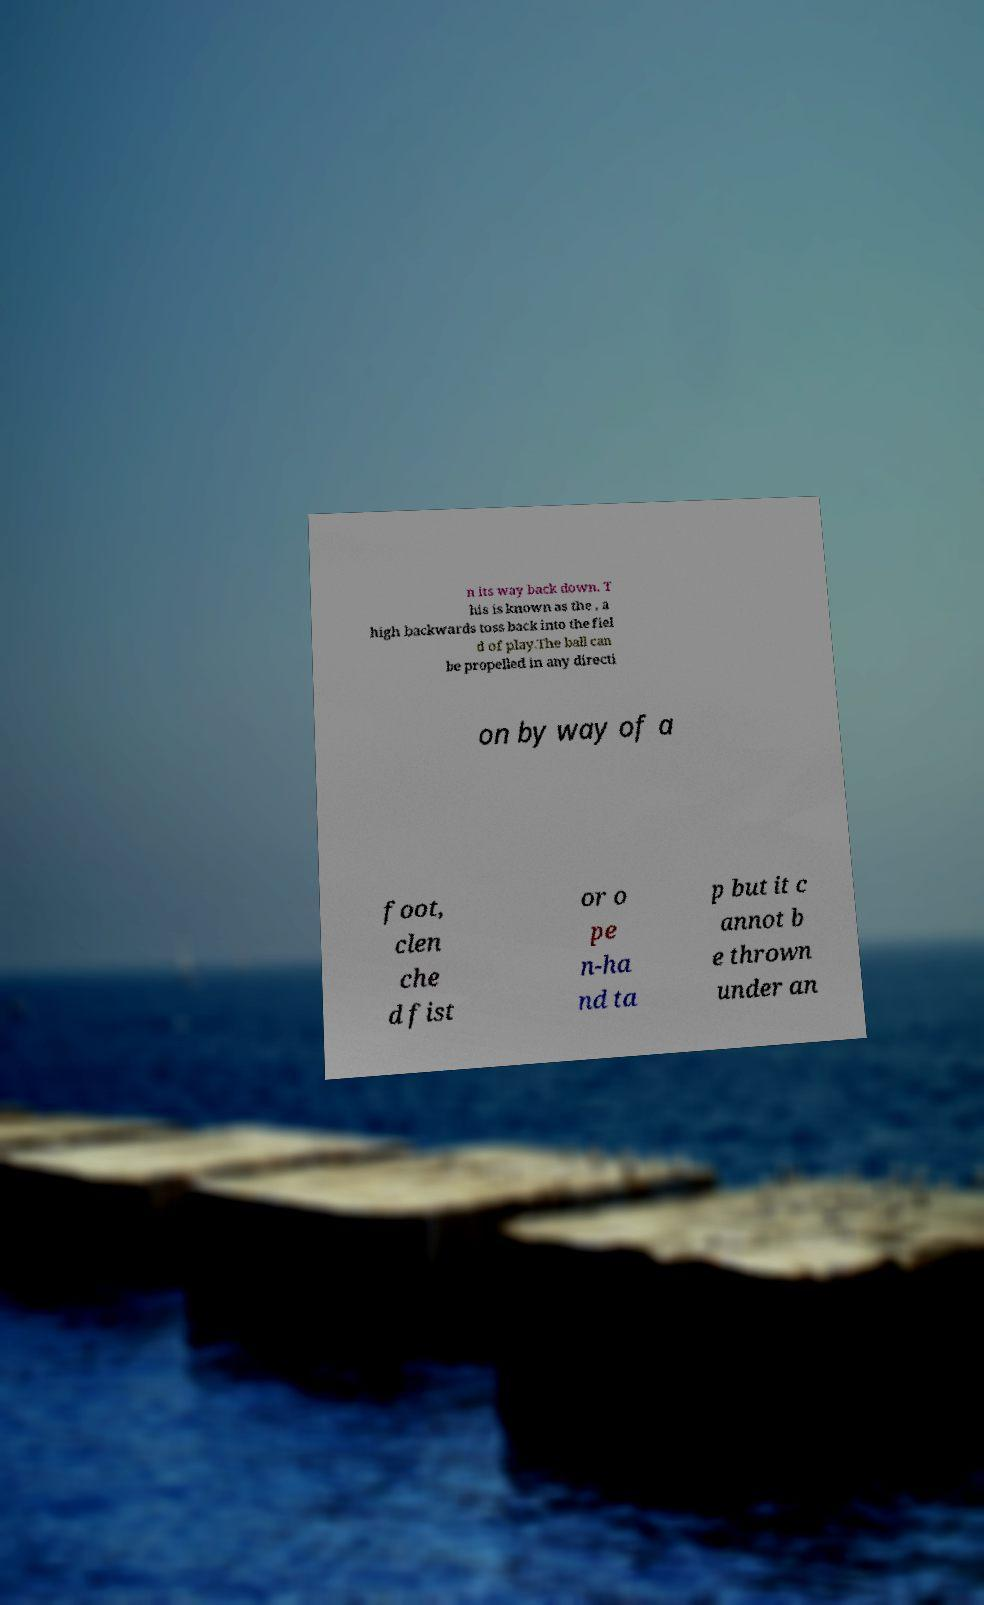Could you assist in decoding the text presented in this image and type it out clearly? n its way back down. T his is known as the , a high backwards toss back into the fiel d of play.The ball can be propelled in any directi on by way of a foot, clen che d fist or o pe n-ha nd ta p but it c annot b e thrown under an 